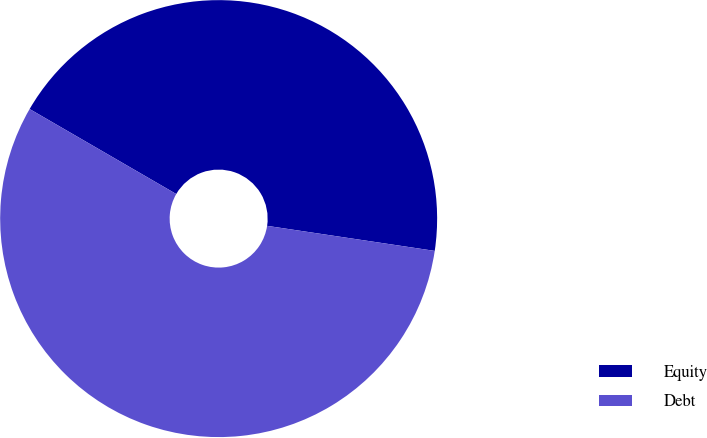Convert chart to OTSL. <chart><loc_0><loc_0><loc_500><loc_500><pie_chart><fcel>Equity<fcel>Debt<nl><fcel>44.0%<fcel>56.0%<nl></chart> 